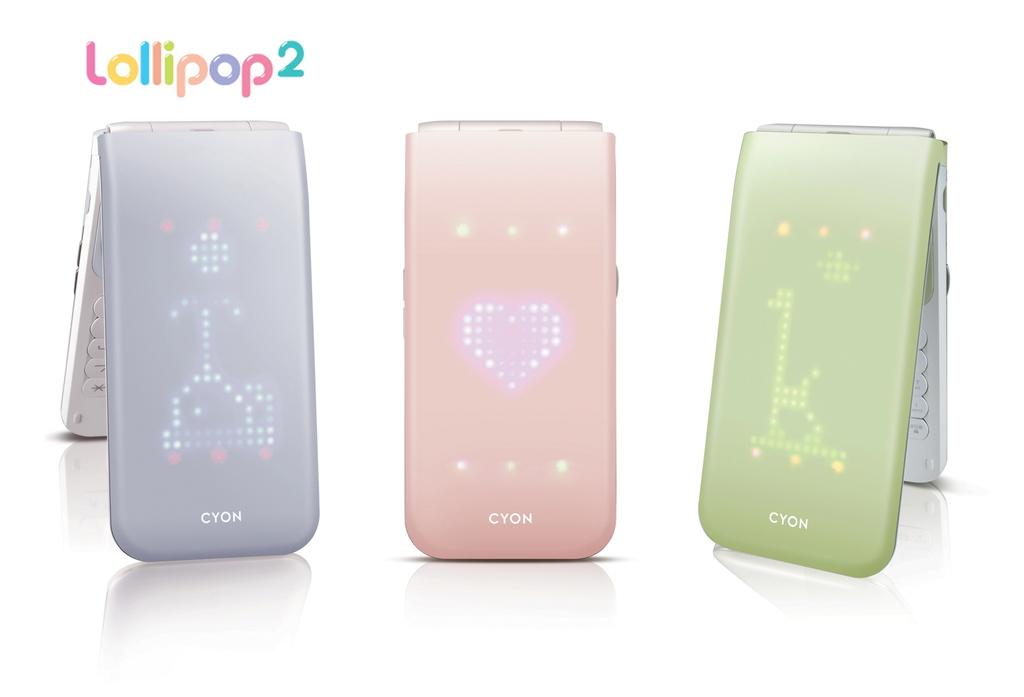What is the brand of the phone?
Your answer should be very brief. Cyon. What model name is written on the bottom of all 3 phones?
Keep it short and to the point. Cyon. 